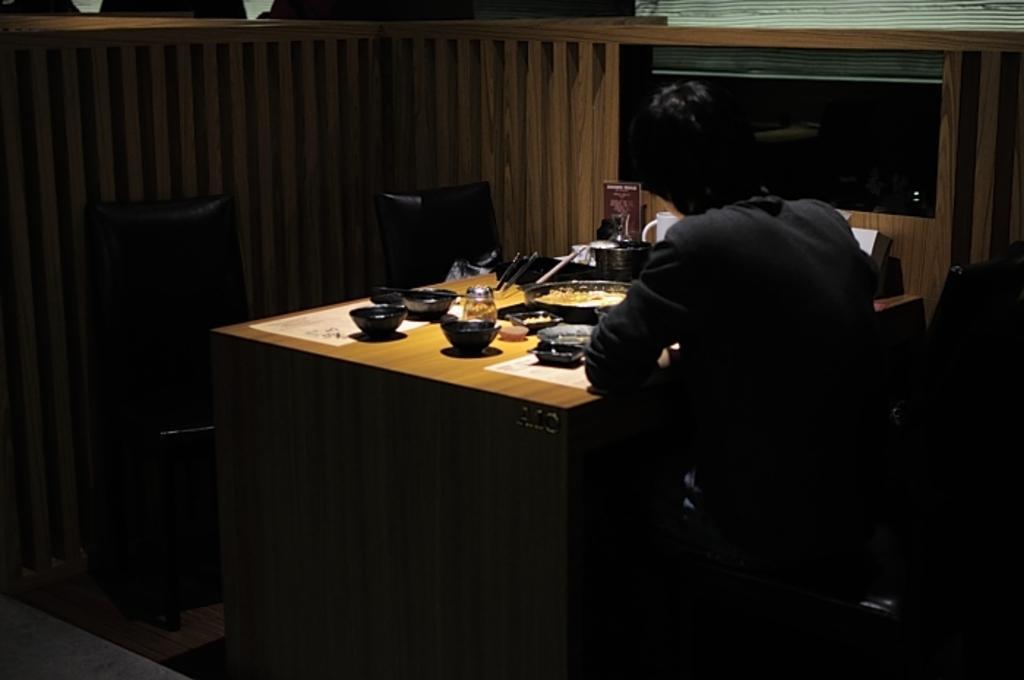Could you give a brief overview of what you see in this image? As we can see in the image, there is a man sitting on chair. In front of him there is a table. On table there are bowls, plate and glasses. 